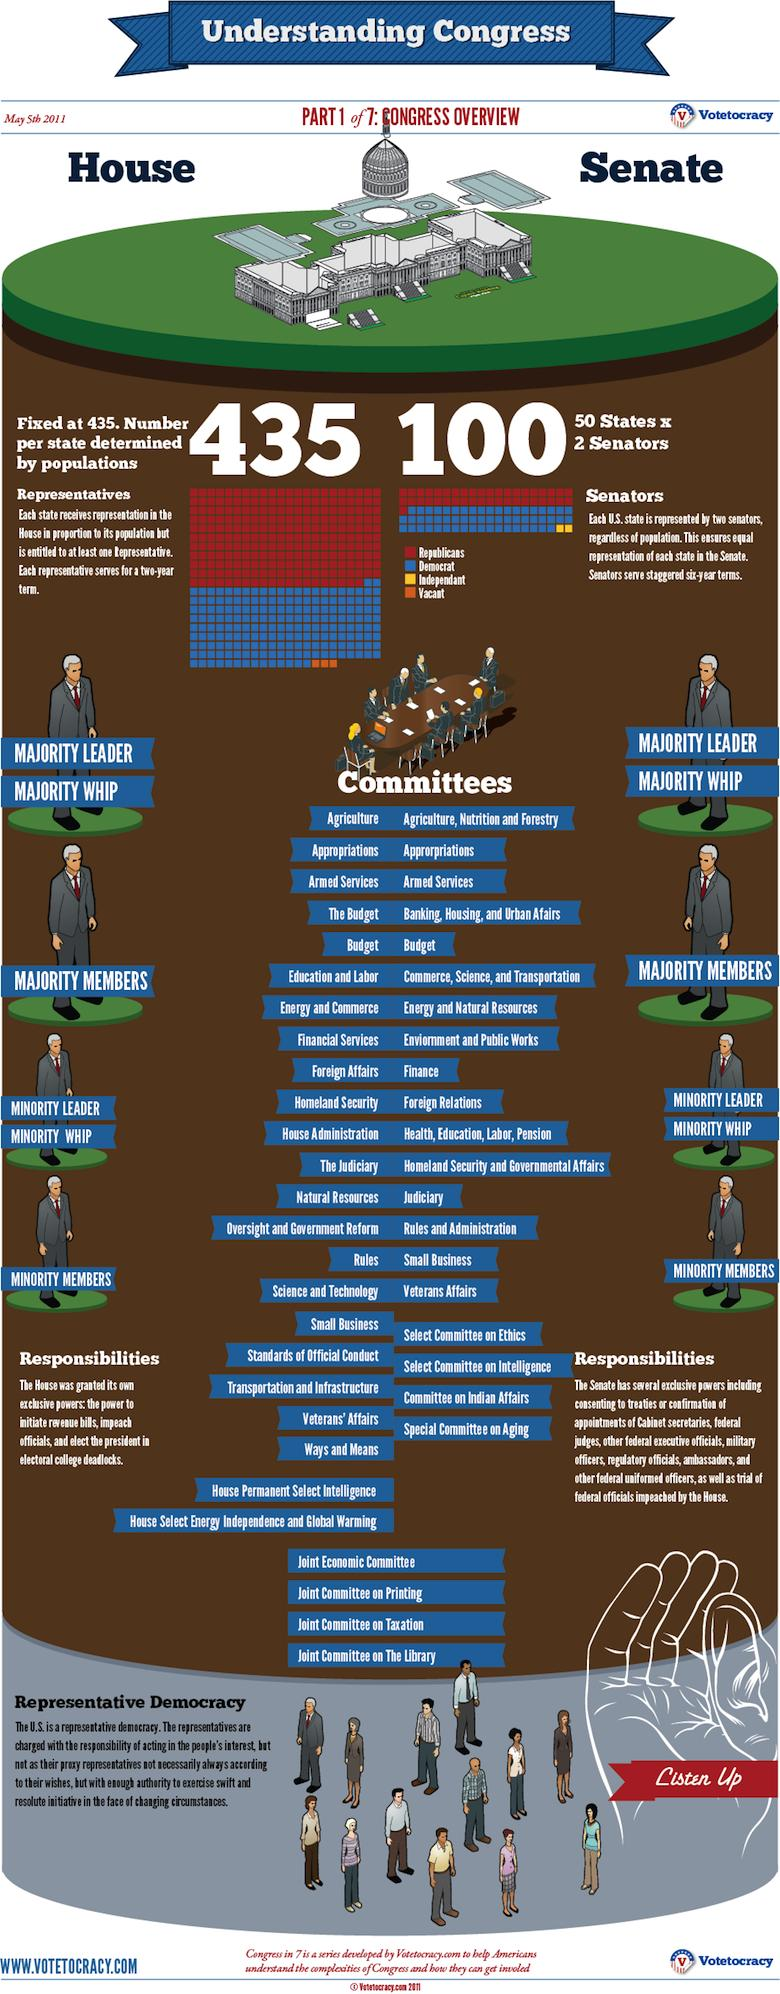Outline some significant characteristics in this image. The number of blocks necessary to represent the word 'independent' is two. The color that used to represent "democrat" is yellow. Thirty-three blocks symbolize "vacant," according to the information provided. 